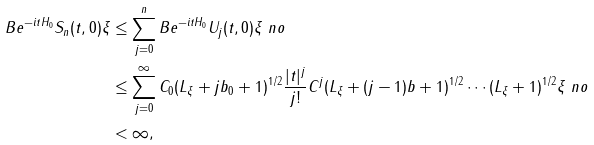Convert formula to latex. <formula><loc_0><loc_0><loc_500><loc_500>\| B e ^ { - i t H _ { 0 } } S _ { n } ( t , 0 ) \xi \| & \leq \sum _ { j = 0 } ^ { n } \| B e ^ { - i t H _ { 0 } } U _ { j } ( t , 0 ) \xi \| \ n o \\ & \leq \sum _ { j = 0 } ^ { \infty } C _ { 0 } ( L _ { \xi } + j b _ { 0 } + 1 ) ^ { 1 / 2 } \frac { | t | ^ { j } } { j ! } C ^ { j } ( L _ { \xi } + ( j - 1 ) b + 1 ) ^ { 1 / 2 } \cdots ( L _ { \xi } + 1 ) ^ { 1 / 2 } \| \xi \| \ n o \\ & < \infty ,</formula> 